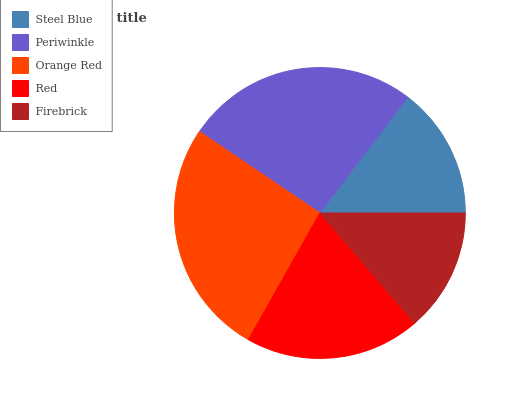Is Firebrick the minimum?
Answer yes or no. Yes. Is Orange Red the maximum?
Answer yes or no. Yes. Is Periwinkle the minimum?
Answer yes or no. No. Is Periwinkle the maximum?
Answer yes or no. No. Is Periwinkle greater than Steel Blue?
Answer yes or no. Yes. Is Steel Blue less than Periwinkle?
Answer yes or no. Yes. Is Steel Blue greater than Periwinkle?
Answer yes or no. No. Is Periwinkle less than Steel Blue?
Answer yes or no. No. Is Red the high median?
Answer yes or no. Yes. Is Red the low median?
Answer yes or no. Yes. Is Periwinkle the high median?
Answer yes or no. No. Is Firebrick the low median?
Answer yes or no. No. 